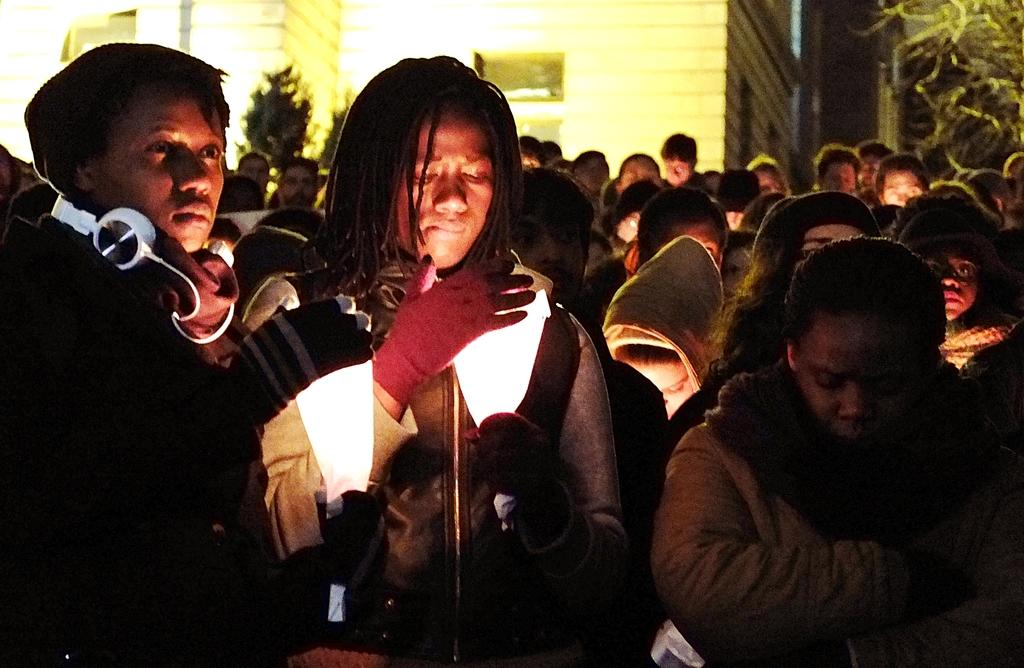How many people are in the image? There is a group of people in the image, but the exact number cannot be determined from the provided facts. What is the person holding in the image? A person is holding an object in the image, but the specific object cannot be identified from the provided facts. What type of structure is visible in the image? There is a building in the image. What type of vegetation is present in the image? There are trees in the image. Where is the faucet located in the image? There is no faucet present in the image. What type of joke is being told by the group of people in the image? There is no indication of a joke being told in the image, as the facts do not mention any conversation or interaction among the people. 